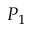<formula> <loc_0><loc_0><loc_500><loc_500>P _ { 1 }</formula> 